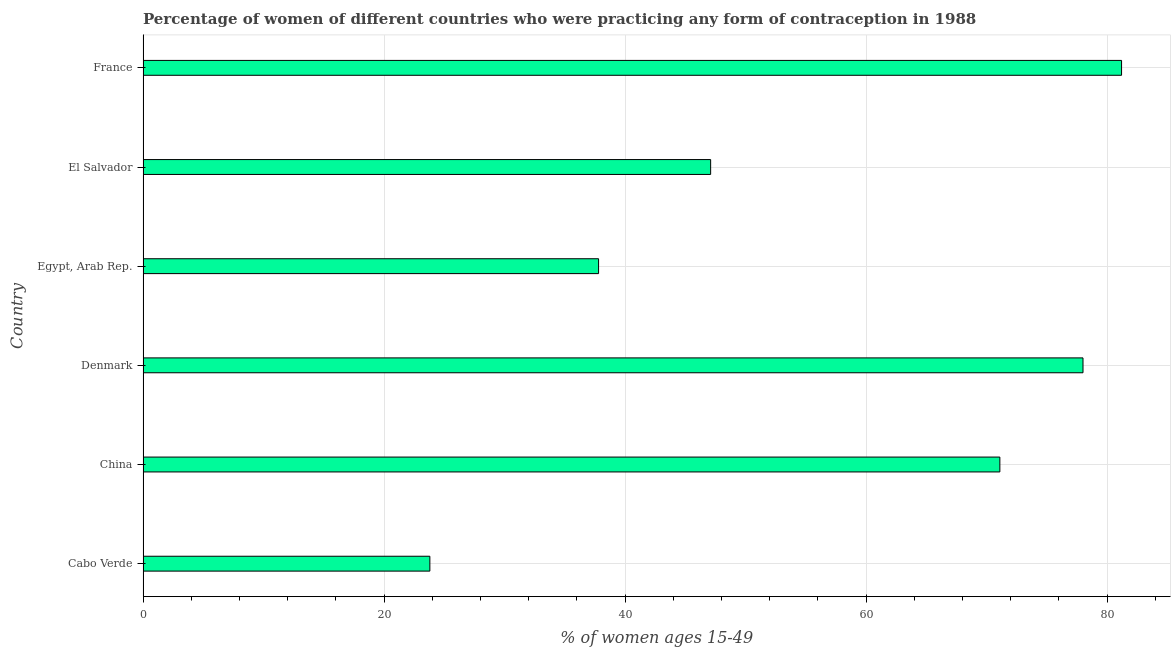Does the graph contain grids?
Offer a terse response. Yes. What is the title of the graph?
Offer a very short reply. Percentage of women of different countries who were practicing any form of contraception in 1988. What is the label or title of the X-axis?
Your answer should be compact. % of women ages 15-49. What is the label or title of the Y-axis?
Offer a very short reply. Country. What is the contraceptive prevalence in El Salvador?
Make the answer very short. 47.1. Across all countries, what is the maximum contraceptive prevalence?
Give a very brief answer. 81.2. Across all countries, what is the minimum contraceptive prevalence?
Make the answer very short. 23.8. In which country was the contraceptive prevalence maximum?
Your response must be concise. France. In which country was the contraceptive prevalence minimum?
Your response must be concise. Cabo Verde. What is the sum of the contraceptive prevalence?
Provide a short and direct response. 339. What is the difference between the contraceptive prevalence in El Salvador and France?
Your answer should be compact. -34.1. What is the average contraceptive prevalence per country?
Your response must be concise. 56.5. What is the median contraceptive prevalence?
Make the answer very short. 59.1. What is the ratio of the contraceptive prevalence in Cabo Verde to that in El Salvador?
Your answer should be compact. 0.51. Is the difference between the contraceptive prevalence in Egypt, Arab Rep. and France greater than the difference between any two countries?
Give a very brief answer. No. What is the difference between the highest and the second highest contraceptive prevalence?
Your response must be concise. 3.2. What is the difference between the highest and the lowest contraceptive prevalence?
Your answer should be compact. 57.4. In how many countries, is the contraceptive prevalence greater than the average contraceptive prevalence taken over all countries?
Your response must be concise. 3. How many countries are there in the graph?
Keep it short and to the point. 6. What is the difference between two consecutive major ticks on the X-axis?
Ensure brevity in your answer.  20. What is the % of women ages 15-49 of Cabo Verde?
Offer a terse response. 23.8. What is the % of women ages 15-49 of China?
Keep it short and to the point. 71.1. What is the % of women ages 15-49 of Denmark?
Provide a short and direct response. 78. What is the % of women ages 15-49 of Egypt, Arab Rep.?
Give a very brief answer. 37.8. What is the % of women ages 15-49 in El Salvador?
Your answer should be very brief. 47.1. What is the % of women ages 15-49 in France?
Give a very brief answer. 81.2. What is the difference between the % of women ages 15-49 in Cabo Verde and China?
Provide a succinct answer. -47.3. What is the difference between the % of women ages 15-49 in Cabo Verde and Denmark?
Ensure brevity in your answer.  -54.2. What is the difference between the % of women ages 15-49 in Cabo Verde and El Salvador?
Offer a terse response. -23.3. What is the difference between the % of women ages 15-49 in Cabo Verde and France?
Offer a very short reply. -57.4. What is the difference between the % of women ages 15-49 in China and Egypt, Arab Rep.?
Make the answer very short. 33.3. What is the difference between the % of women ages 15-49 in China and France?
Provide a short and direct response. -10.1. What is the difference between the % of women ages 15-49 in Denmark and Egypt, Arab Rep.?
Provide a succinct answer. 40.2. What is the difference between the % of women ages 15-49 in Denmark and El Salvador?
Your answer should be compact. 30.9. What is the difference between the % of women ages 15-49 in Denmark and France?
Provide a succinct answer. -3.2. What is the difference between the % of women ages 15-49 in Egypt, Arab Rep. and El Salvador?
Keep it short and to the point. -9.3. What is the difference between the % of women ages 15-49 in Egypt, Arab Rep. and France?
Keep it short and to the point. -43.4. What is the difference between the % of women ages 15-49 in El Salvador and France?
Offer a very short reply. -34.1. What is the ratio of the % of women ages 15-49 in Cabo Verde to that in China?
Ensure brevity in your answer.  0.34. What is the ratio of the % of women ages 15-49 in Cabo Verde to that in Denmark?
Keep it short and to the point. 0.3. What is the ratio of the % of women ages 15-49 in Cabo Verde to that in Egypt, Arab Rep.?
Your answer should be compact. 0.63. What is the ratio of the % of women ages 15-49 in Cabo Verde to that in El Salvador?
Your answer should be compact. 0.51. What is the ratio of the % of women ages 15-49 in Cabo Verde to that in France?
Provide a succinct answer. 0.29. What is the ratio of the % of women ages 15-49 in China to that in Denmark?
Ensure brevity in your answer.  0.91. What is the ratio of the % of women ages 15-49 in China to that in Egypt, Arab Rep.?
Your answer should be very brief. 1.88. What is the ratio of the % of women ages 15-49 in China to that in El Salvador?
Provide a short and direct response. 1.51. What is the ratio of the % of women ages 15-49 in China to that in France?
Your answer should be very brief. 0.88. What is the ratio of the % of women ages 15-49 in Denmark to that in Egypt, Arab Rep.?
Offer a terse response. 2.06. What is the ratio of the % of women ages 15-49 in Denmark to that in El Salvador?
Provide a short and direct response. 1.66. What is the ratio of the % of women ages 15-49 in Denmark to that in France?
Ensure brevity in your answer.  0.96. What is the ratio of the % of women ages 15-49 in Egypt, Arab Rep. to that in El Salvador?
Offer a very short reply. 0.8. What is the ratio of the % of women ages 15-49 in Egypt, Arab Rep. to that in France?
Ensure brevity in your answer.  0.47. What is the ratio of the % of women ages 15-49 in El Salvador to that in France?
Provide a succinct answer. 0.58. 